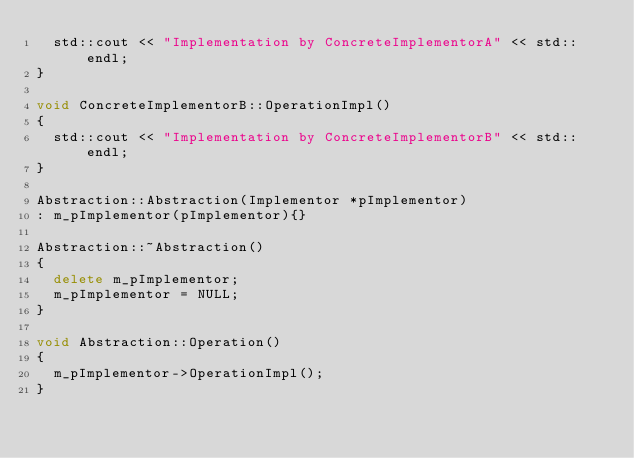<code> <loc_0><loc_0><loc_500><loc_500><_C++_>	std::cout << "Implementation by ConcreteImplementorA" << std::endl;
}

void ConcreteImplementorB::OperationImpl()
{
	std::cout << "Implementation by ConcreteImplementorB" << std::endl;
}

Abstraction::Abstraction(Implementor *pImplementor)
: m_pImplementor(pImplementor){}

Abstraction::~Abstraction()
{
	delete m_pImplementor;
	m_pImplementor = NULL;
}

void Abstraction::Operation()
{
	m_pImplementor->OperationImpl();
}

</code> 